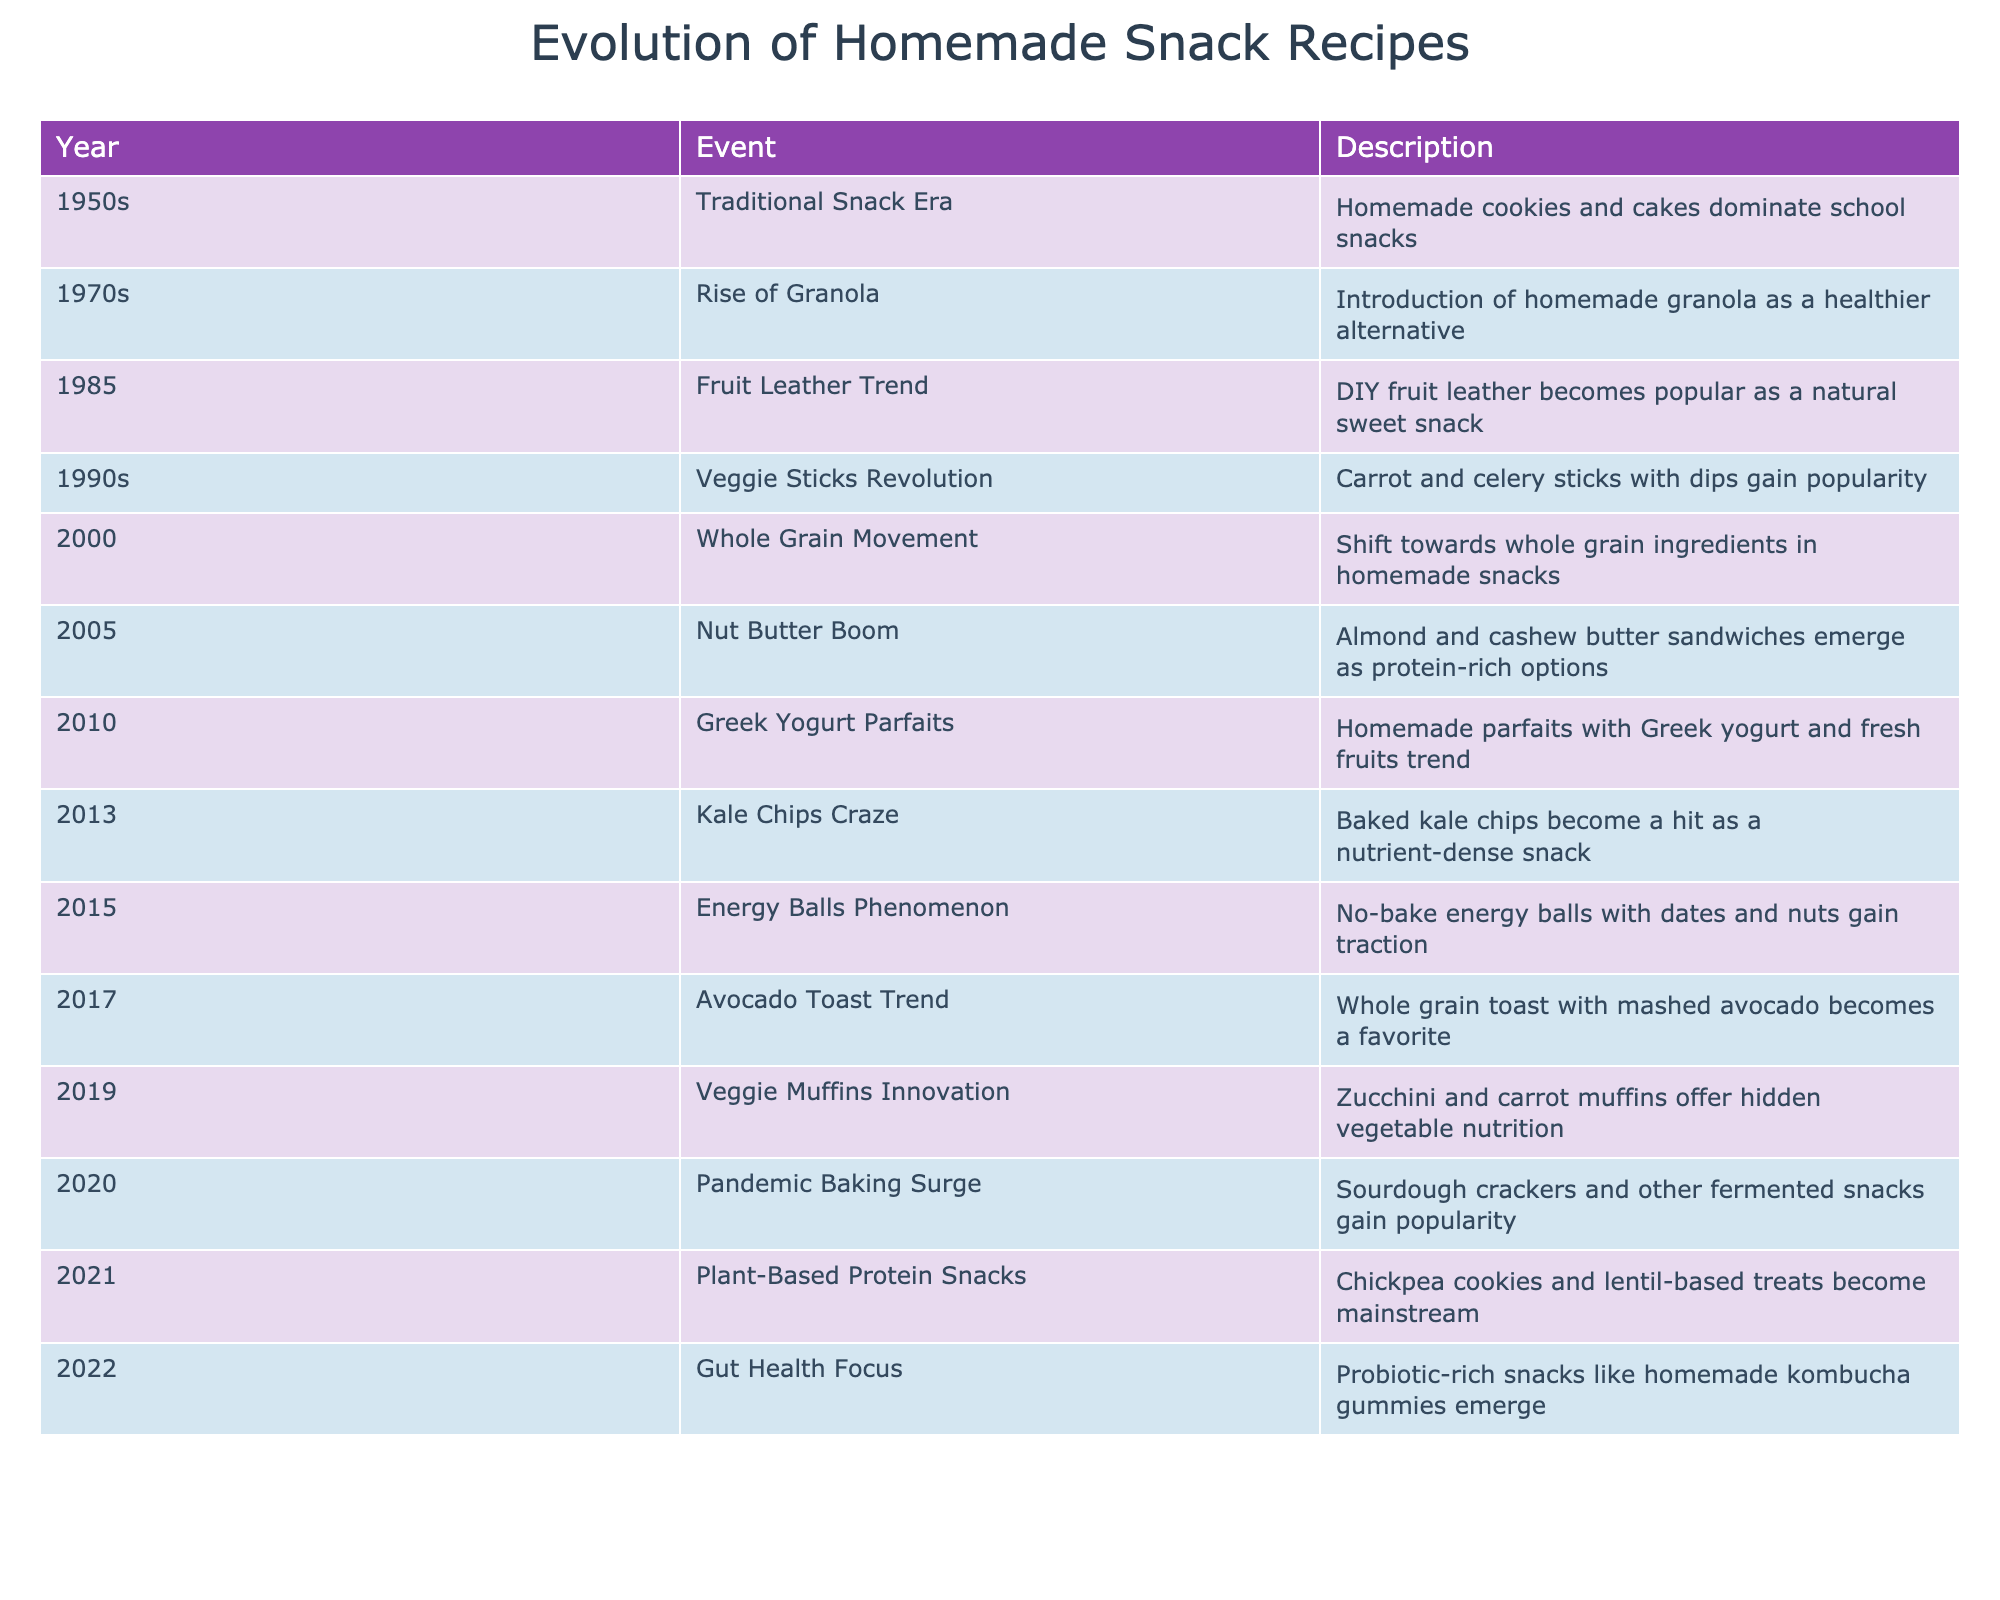What year did the homemade granola trend begin? The table lists the event "Rise of Granola" in the year 1970s. Therefore, granola began as a trend in that decade.
Answer: 1970s Which snack became popular in the 2010s as a healthy option? In the table, two snacks are noted in the 2010s: "Greek Yogurt Parfaits" in 2010 and "Energy Balls" in 2015. Both represent healthy options that gained popularity during this decade.
Answer: Greek Yogurt Parfaits, Energy Balls What is the trend following the "Veggie Sticks Revolution" in the 1990s? The event following the "Veggie Sticks Revolution" is the "Whole Grain Movement" in 2000, indicating a shift in focus towards whole grain ingredients in homemade snacks.
Answer: Whole Grain Movement How many snack trends focus on plant-based ingredients from 2020 onwards? From 2020 (Pandemic Baking Surge) onwards, there are three trends: "Plant-Based Protein Snacks" in 2021 and "Gut Health Focus" in 2022. Counting these gives us a total of three.
Answer: 3 Did energy balls emerge before or after the kale chips craze? The "Kale Chips Craze" is noted in 2013, while "Energy Balls Phenomenon" is in 2015. Since 2015 comes after 2013, energy balls emerged later.
Answer: After Which decade saw the emergence of both fruit leather and veggie sticks? Fruit leather became popular in 1985 and veggie sticks in the 1990s. Hence, both events emerged in the 1980s and 1990s, respectively. Thus, the relevant decades are the 1980s and 1990s.
Answer: 1980s and 1990s What snack trend experienced a surge in popularity due to the pandemic? The trend noted in the table for the pandemic is "Pandemic Baking Surge," emphasizing the rise of sourdough crackers and other fermented snacks in 2020.
Answer: Pandemic Baking Surge How does the introduction of gut health-focused snacks in 2022 compare to previous trends? The first instance of gut health being specifically mentioned is in 2022 with the introduction of probiotic-rich snacks. Previous trends do not explicitly address gut health, indicating a new focus emerged in 2022.
Answer: A new focus on gut health 